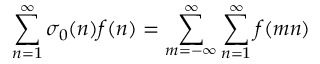<formula> <loc_0><loc_0><loc_500><loc_500>\sum _ { n = 1 } ^ { \infty } \sigma _ { 0 } ( n ) f ( n ) = \sum _ { m = - \infty } ^ { \infty } \sum _ { n = 1 } ^ { \infty } f ( m n )</formula> 